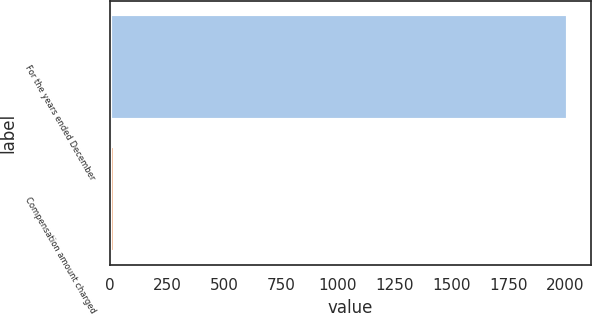Convert chart to OTSL. <chart><loc_0><loc_0><loc_500><loc_500><bar_chart><fcel>For the years ended December<fcel>Compensation amount charged<nl><fcel>2011<fcel>21<nl></chart> 